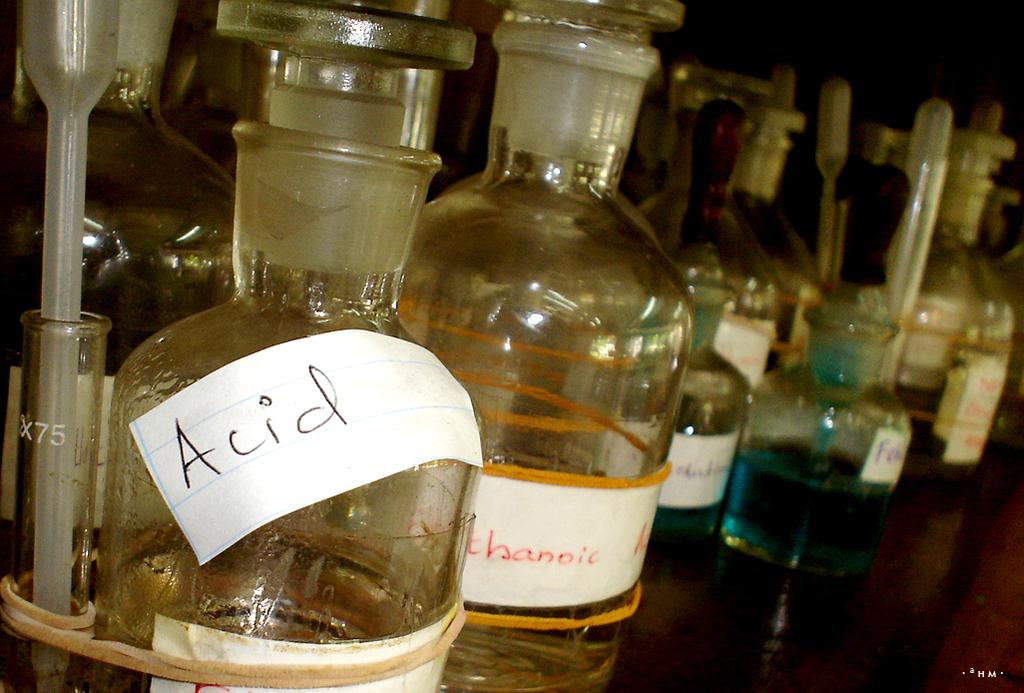What type of containers are visible in the image? There are chemical bottles in the image. Where are the bottles located? The bottles are placed on a shelf. What type of substance is contained in one of the bottles? There is a bottle containing acid in the image. What material are the bottles made of? The bottles are made of glass. What side of the shelf is the bottle with a mark on it located? There is no mention of a bottle with a mark in the provided facts, so we cannot answer this question. 